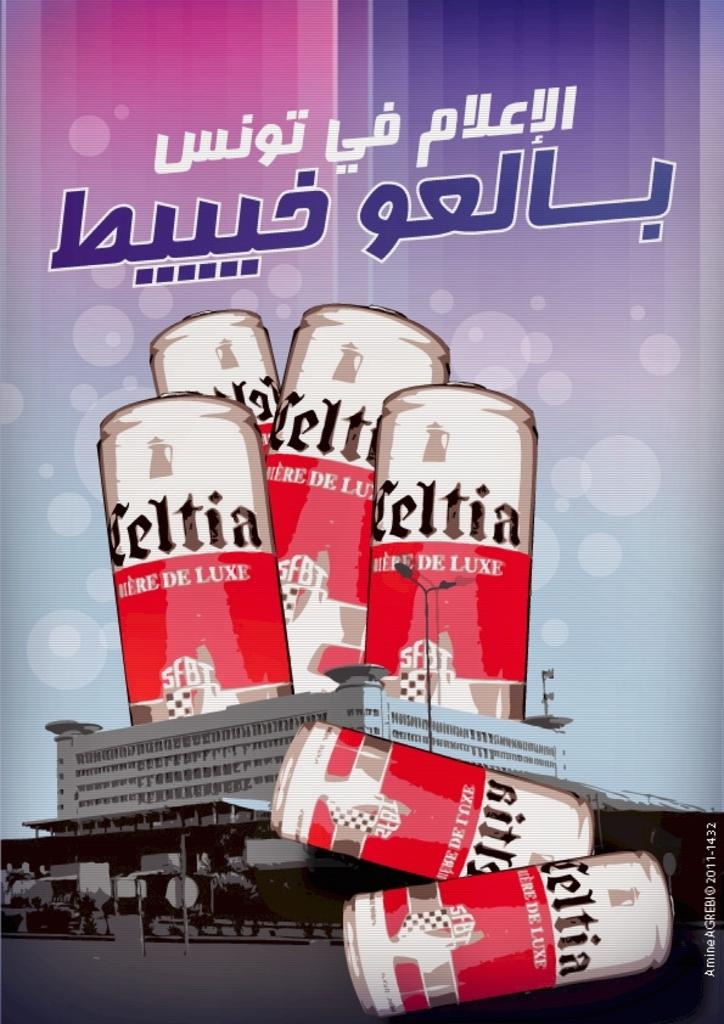<image>
Present a compact description of the photo's key features. An advertisemen shows several large cans of Celtia Deluxe o top of a building. 